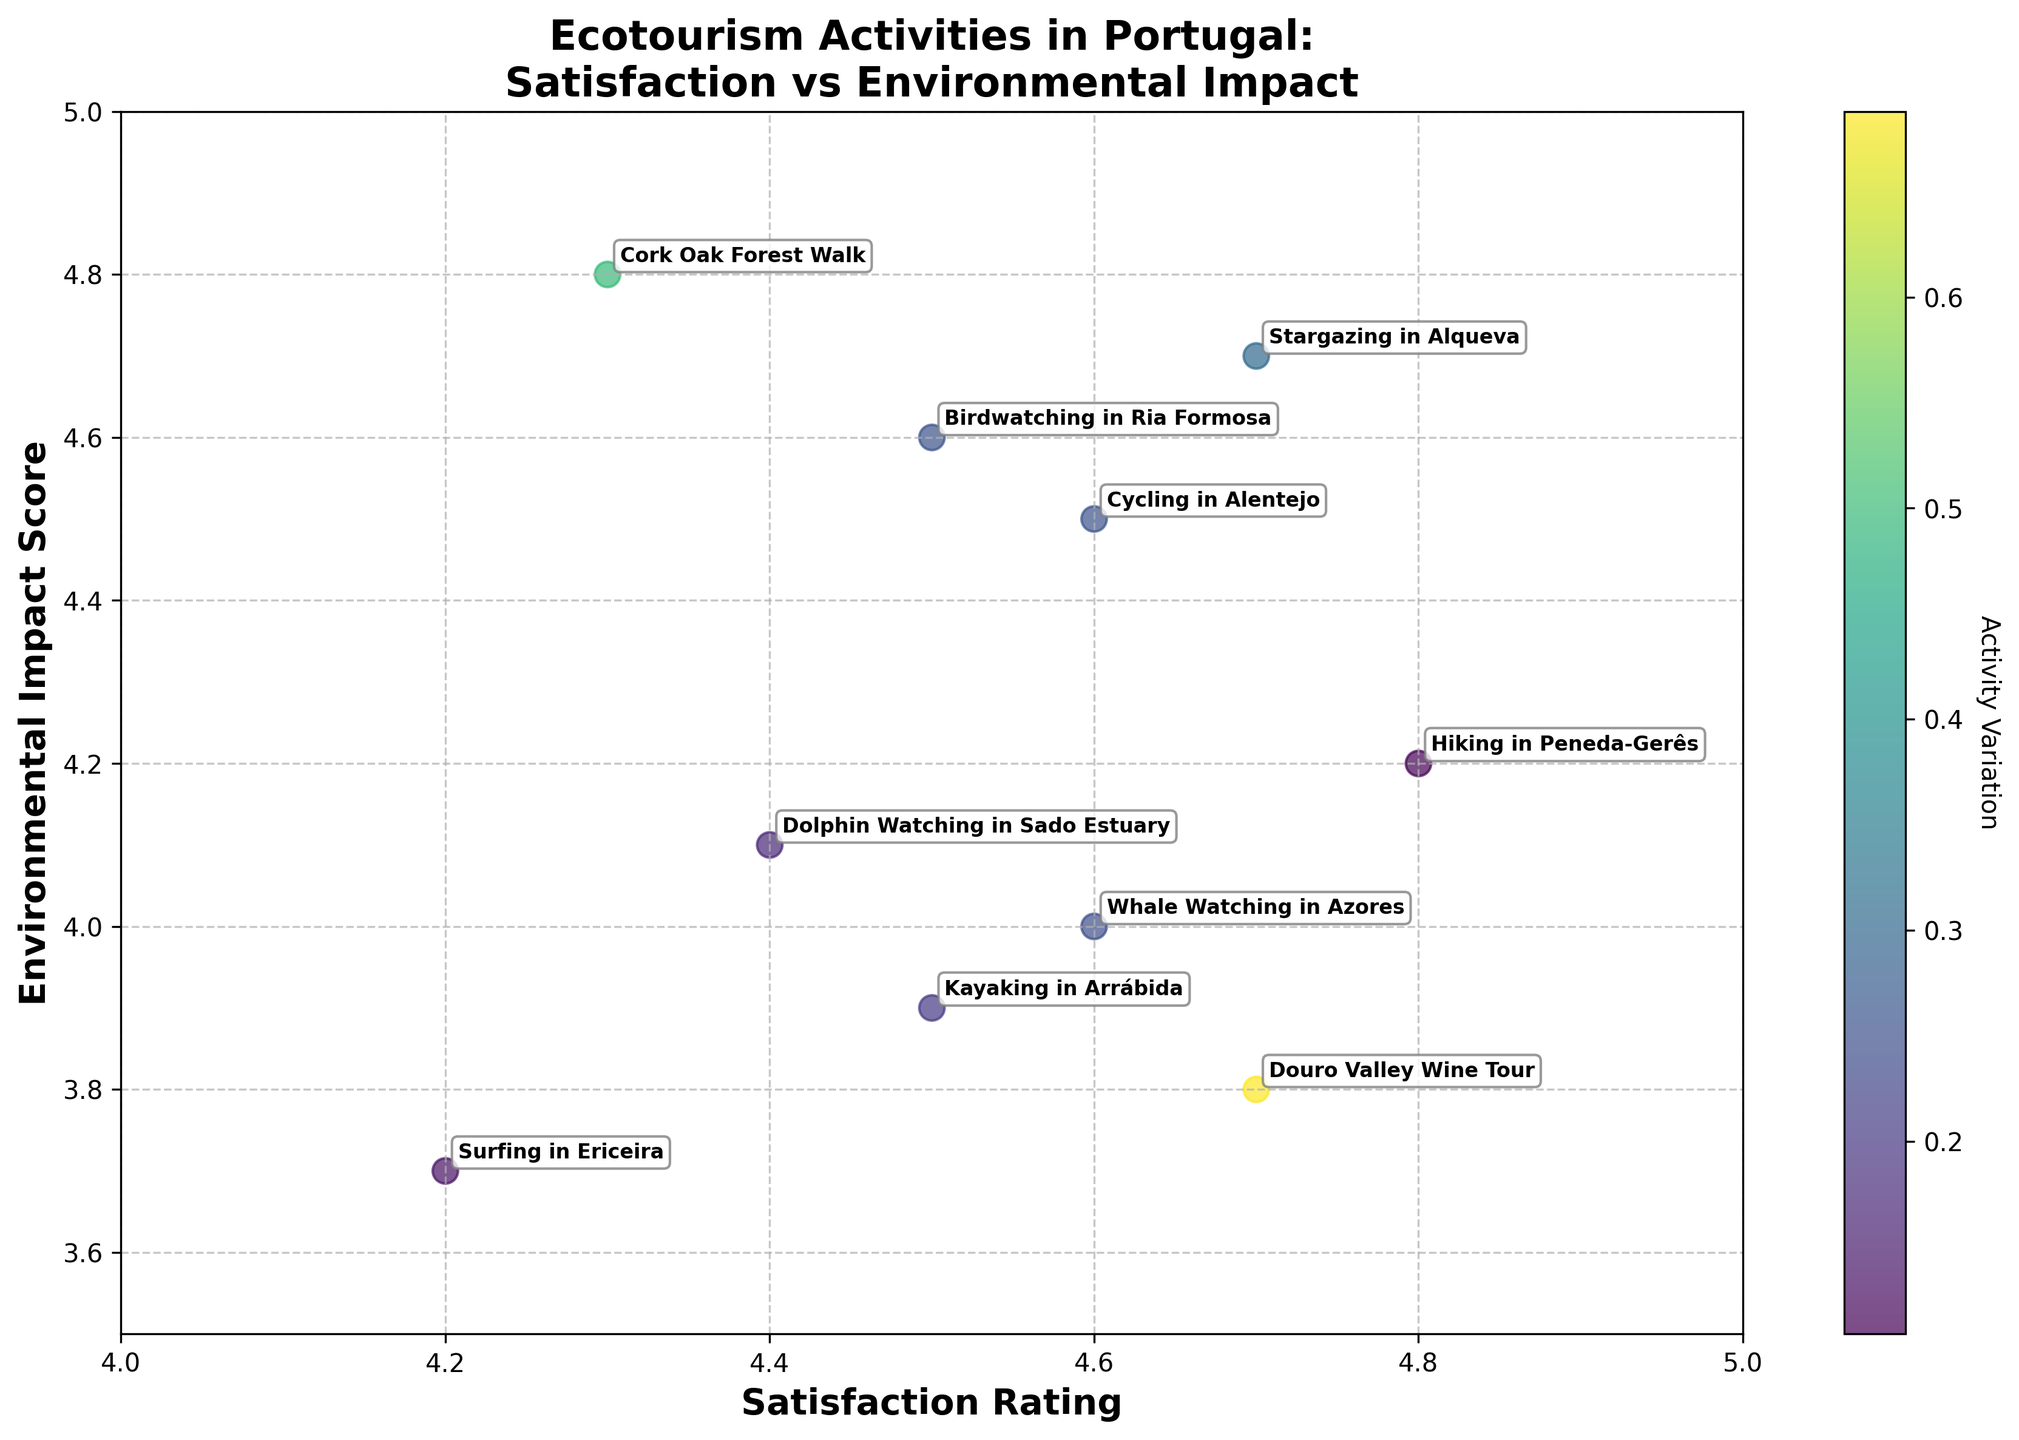What is the title of the plot? The title is always prominently displayed at the top of the plot. The title in the plot reads, "Ecotourism Activities in Portugal: Satisfaction vs Environmental Impact."
Answer: Ecotourism Activities in Portugal: Satisfaction vs Environmental Impact How many data points are there in the plot? To find the number of data points, count the number of distinct points annotated with activity names. Each annotation corresponds to one data point. There are 10 activities listed, thus 10 data points.
Answer: 10 Which activity has the highest satisfaction rating? Look at the x-axis which represents satisfaction rating. The activity with the highest horizontal position has the highest satisfaction rating. "Hiking in Peneda-Gerês" has the highest satisfaction rating at 4.8.
Answer: Hiking in Peneda-Gerês Which activity has the lowest environmental impact score? Review the y-axis, which indicates the environmental impact score. The activity with the lowest vertical position has the lowest environmental impact score. "Surfing in Ericeira" has the lowest environmental impact score at 3.7.
Answer: Surfing in Ericeira Which activity scores highest for both satisfaction and environmental impact? Identify the activities that are furthest to the right (highest satisfaction) and highest vertically (highest environmental impact) on the plot. "Stargazing in Alqueva" stands out in both dimensions with high ratings in satisfaction and environmental impact.
Answer: Stargazing in Alqueva Which activity has a higher satisfaction rating: "Birdwatching in Ria Formosa" or "Kayaking in Arrábida"? Compare the x-axis positions of the points labeled with these activities. "Birdwatching in Ria Formosa" has a satisfaction rating of 4.5, while "Kayaking in Arrábida" also has 4.5. Both activities have the same satisfaction rating.
Answer: Both have 4.5 What is the difference in environmental impact between "Dolphin Watching in Sado Estuary" and "Cork Oak Forest Walk"? Find the y-axis positions of these activities and subtract the lower position value from the higher one. "Dolphin Watching in Sado Estuary" has a score of 4.1, and "Cork Oak Forest Walk" has 4.8. The difference is 4.8 - 4.1 = 0.7.
Answer: 0.7 What is the median satisfaction rating of all the activities? Order the satisfaction ratings from lowest to highest: [4.2, 4.3, 4.4, 4.5, 4.5, 4.6, 4.6, 4.6, 4.7, 4.8]. With 10 data points, the median is the average of the 5th and 6th values: (4.5 + 4.6) / 2 = 4.55.
Answer: 4.55 Is there any activity that has both low satisfaction and low environmental impact? Define "low" as below the midpoint of the respective axes (both below 4.5). Then check activities falling in this lower-left quadrant: Only "Surfing in Ericeira" fits both criteria with scores 4.2 (satisfaction) and 3.7 (impact).
Answer: Surfing in Ericeira Which activity has a satisfaction rating above 4.6 but an environmental impact score below 4.5? Look for data points right of 4.6 on the x-axis and below 4.5 on the y-axis. "Whale Watching in Azores" satisfies these conditions with 4.6 satisfaction and 4.0 environmental impact.
Answer: Whale Watching in Azores 